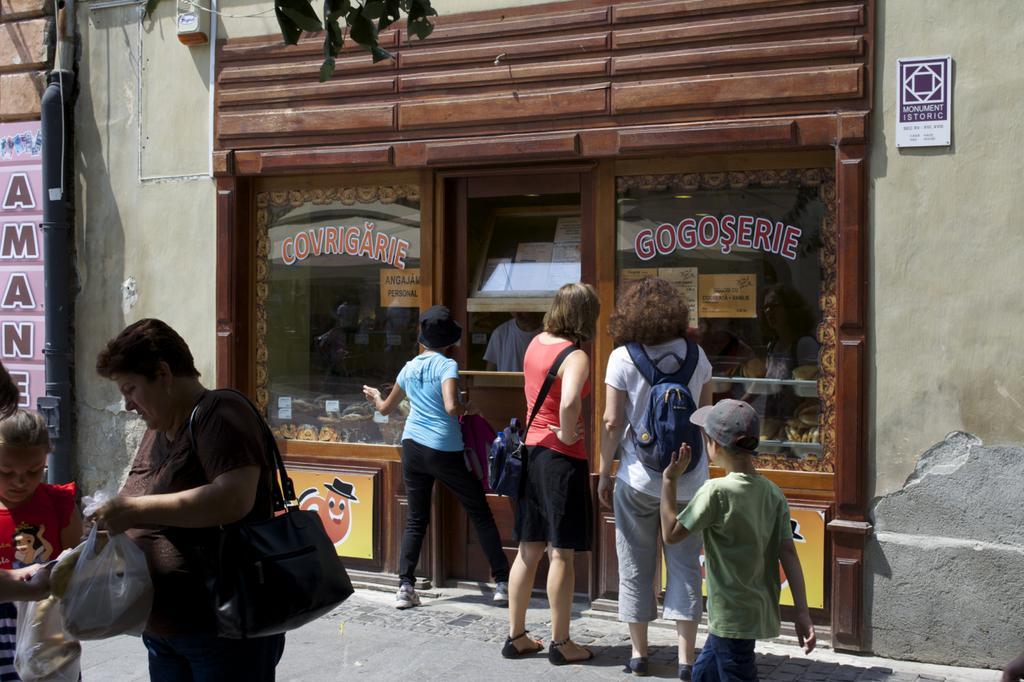Describe this image in one or two sentences. In this image we can see there are a few people standing in front of the stall. On the left side there is a lady standing and holding a handbag and a cover, in front of her there are two kids. 